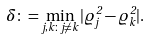<formula> <loc_0><loc_0><loc_500><loc_500>\delta \colon = \min _ { j , k \colon j \ne k } | \varrho _ { j } ^ { 2 } - \varrho _ { k } ^ { 2 } | .</formula> 